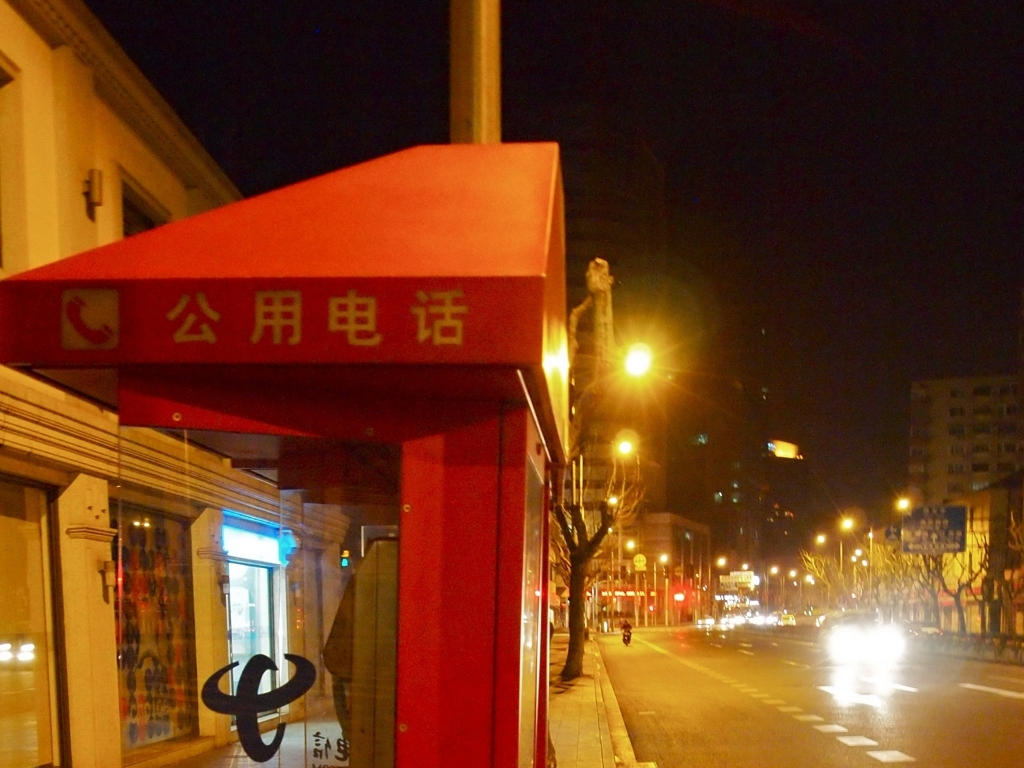Are there any people visible in the photo, and what does that suggest about this location? No people are visible in this image. This, combined with the closed shops and the absence of pedestrian traffic, suggests that the photo was likely taken at a time when people are less active outdoors, such as late at night. 